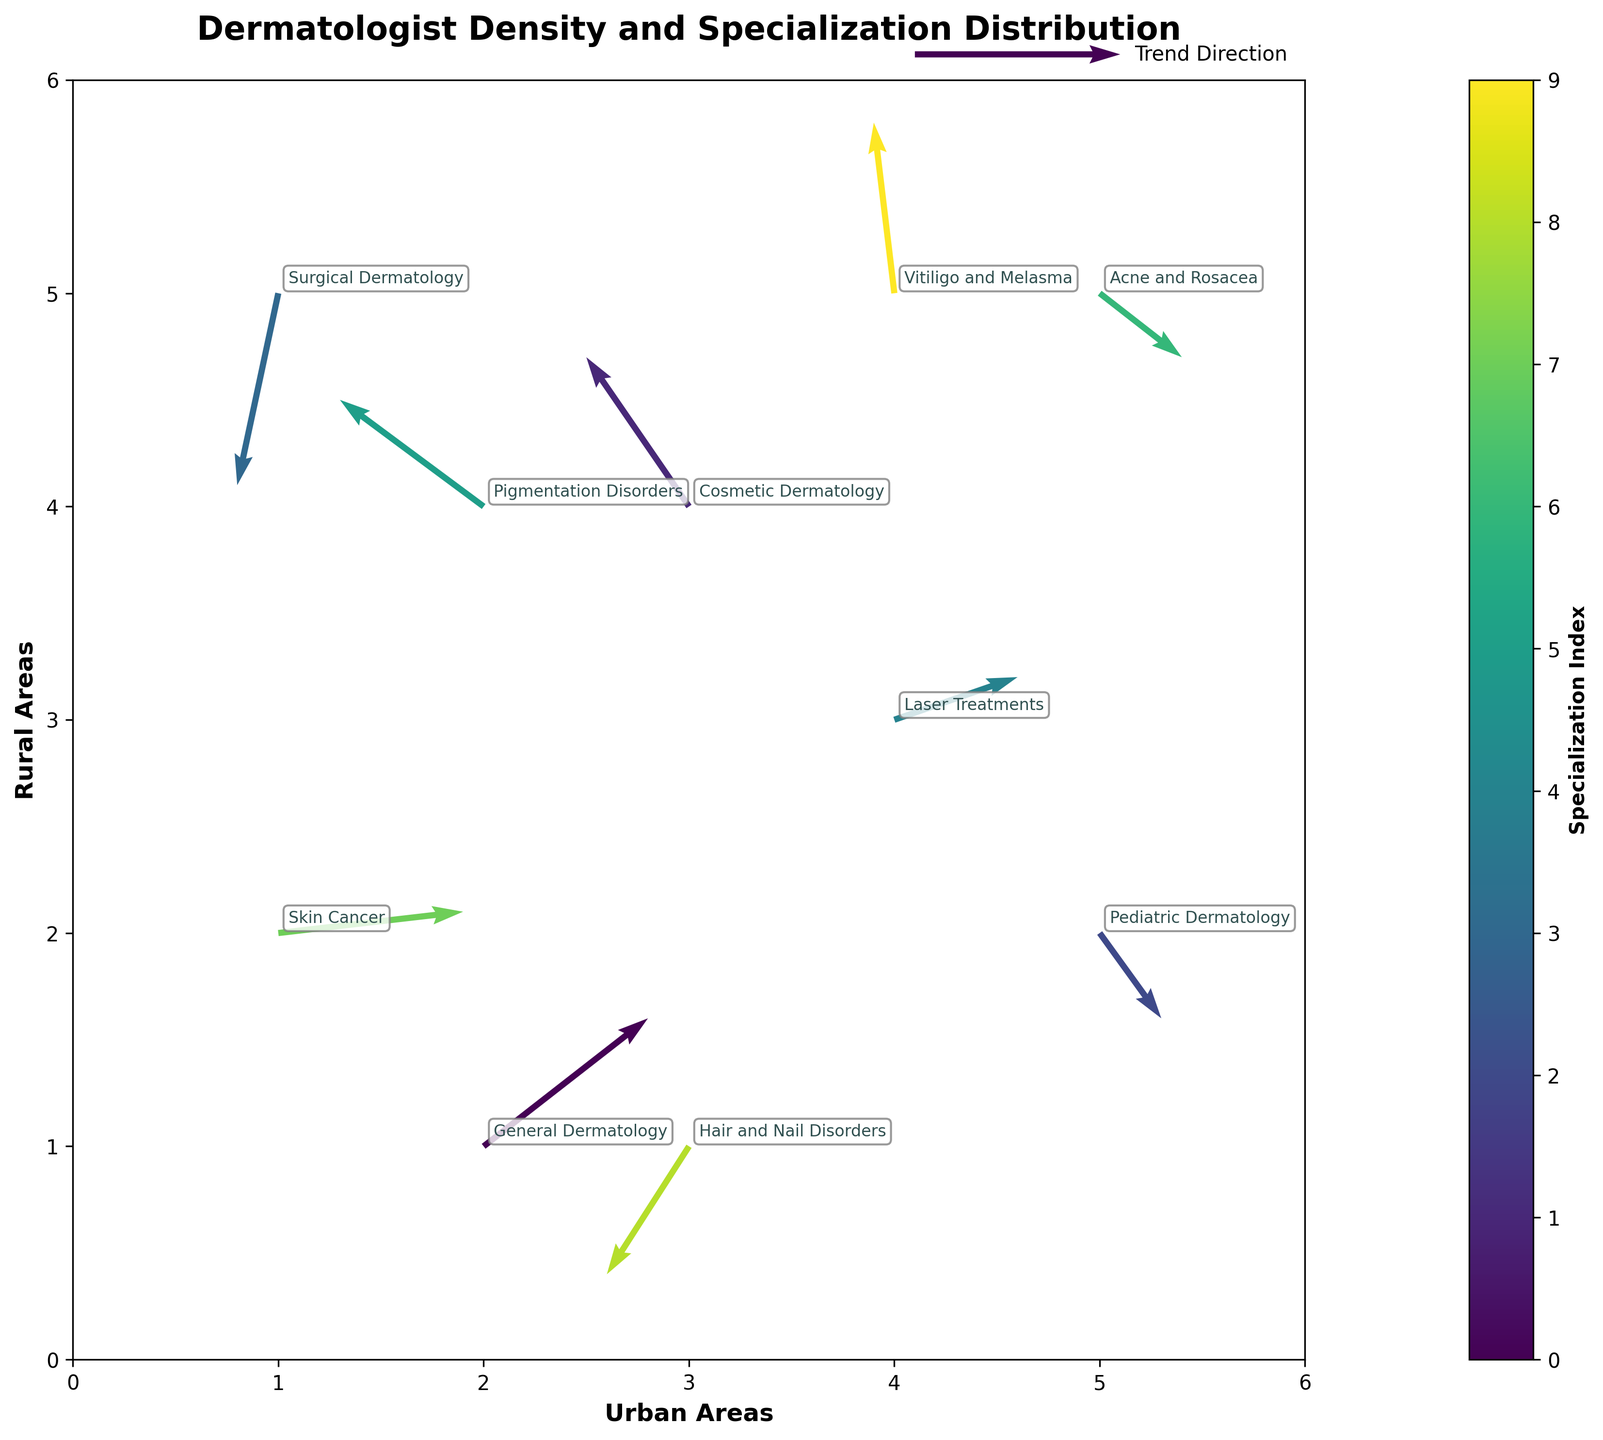How many different dermatology specialties are represented in the plot? There are 10 different data points, each with a unique specialty label, as indicated by the annotations in the quiver plot.
Answer: 10 What is the title of the figure? The title is located at the top center of the plot and reads "Dermatologist Density and Specialization Distribution."
Answer: Dermatologist Density and Specialization Distribution Which dermatology specialty has the highest representation in urban areas (x-axis)? "Skin Cancer" has the highest x-coordinate value of 1, indicating a higher presence in urban areas.
Answer: Skin Cancer Which dermatology specialty shows a strong movement toward rural areas (y-axis)? "Surgical Dermatology" at (1, 5) has a significant negative v vector (-0.9), indicating a movement towards lower y-values (more rural areas).
Answer: Surgical Dermatology Between "Cosmetic Dermatology" and "General Dermatology," which specialty is trending more toward urban areas? "General Dermatology" (2,1) with a positive u vector (0.8) is trending more towards urban areas compared to "Cosmetic Dermatology" (3,4) with a negative u vector (-0.5).
Answer: General Dermatology Among the specialties represented, which one shows the least movement in terms of direction? "Pigmentation Disorders" (2,4) has both vectors u and v close to zero (-0.7, 0.5), indicating the least movement.
Answer: Pigmentation Disorders What specialties are moving towards the bottom-left quadrant (both urban and rural decreases)? "Hair and Nail Disorders" (3,1) and "Cosmetic Dermatology" (3,4) both have negative u and v vectors, indicating movement towards the bottom-left quadrant.
Answer: Hair and Nail Disorders, Cosmetic Dermatology Which specialty shows the greatest increase in rural areas? "Vitiligo and Melasma" (4,5) has the highest positive v vector (0.8), indicating the greatest increase in rural areas.
Answer: Vitiligo and Melasma Compare "Acne and Rosacea" and "Laser Treatments" in terms of their movement towards urban or rural areas. "Acne and Rosacea" (5,5) moves slightly towards urban areas (0.4) and slightly away from rural areas (-0.3), whereas "Laser Treatments" (4,3) moves significantly towards both urban (0.6) and rural (0.2) areas.
Answer: Acne and Rosacea: towards urban, away from rural; Laser Treatments: towards both urban and rural Which dermatology specialty represents a minimal change in its position? "Pigmentation Disorders" (2,4) shows minimal change with vectors close to zero (-0.7, 0.5), indicating hardly any movement.
Answer: Pigmentation Disorders 